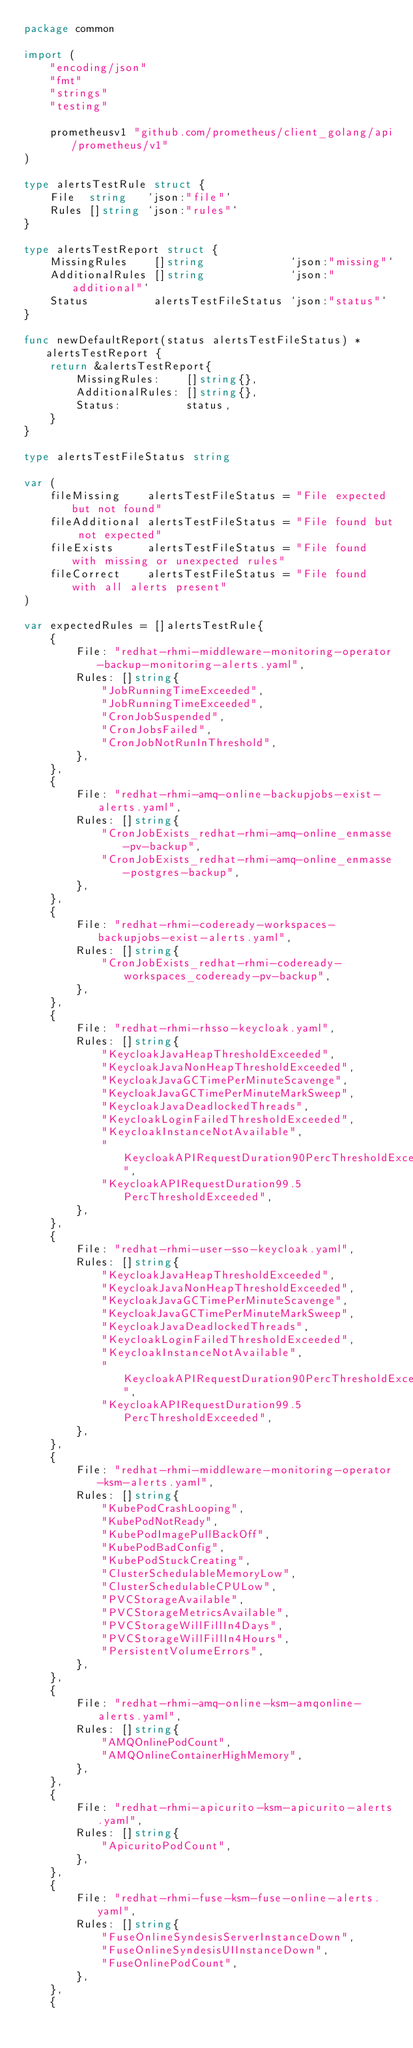<code> <loc_0><loc_0><loc_500><loc_500><_Go_>package common

import (
	"encoding/json"
	"fmt"
	"strings"
	"testing"

	prometheusv1 "github.com/prometheus/client_golang/api/prometheus/v1"
)

type alertsTestRule struct {
	File  string   `json:"file"`
	Rules []string `json:"rules"`
}

type alertsTestReport struct {
	MissingRules    []string             `json:"missing"`
	AdditionalRules []string             `json:"additional"`
	Status          alertsTestFileStatus `json:"status"`
}

func newDefaultReport(status alertsTestFileStatus) *alertsTestReport {
	return &alertsTestReport{
		MissingRules:    []string{},
		AdditionalRules: []string{},
		Status:          status,
	}
}

type alertsTestFileStatus string

var (
	fileMissing    alertsTestFileStatus = "File expected but not found"
	fileAdditional alertsTestFileStatus = "File found but not expected"
	fileExists     alertsTestFileStatus = "File found with missing or unexpected rules"
	fileCorrect    alertsTestFileStatus = "File found with all alerts present"
)

var expectedRules = []alertsTestRule{
	{
		File: "redhat-rhmi-middleware-monitoring-operator-backup-monitoring-alerts.yaml",
		Rules: []string{
			"JobRunningTimeExceeded",
			"JobRunningTimeExceeded",
			"CronJobSuspended",
			"CronJobsFailed",
			"CronJobNotRunInThreshold",
		},
	},
	{
		File: "redhat-rhmi-amq-online-backupjobs-exist-alerts.yaml",
		Rules: []string{
			"CronJobExists_redhat-rhmi-amq-online_enmasse-pv-backup",
			"CronJobExists_redhat-rhmi-amq-online_enmasse-postgres-backup",
		},
	},
	{
		File: "redhat-rhmi-codeready-workspaces-backupjobs-exist-alerts.yaml",
		Rules: []string{
			"CronJobExists_redhat-rhmi-codeready-workspaces_codeready-pv-backup",
		},
	},
	{
		File: "redhat-rhmi-rhsso-keycloak.yaml",
		Rules: []string{
			"KeycloakJavaHeapThresholdExceeded",
			"KeycloakJavaNonHeapThresholdExceeded",
			"KeycloakJavaGCTimePerMinuteScavenge",
			"KeycloakJavaGCTimePerMinuteMarkSweep",
			"KeycloakJavaDeadlockedThreads",
			"KeycloakLoginFailedThresholdExceeded",
			"KeycloakInstanceNotAvailable",
			"KeycloakAPIRequestDuration90PercThresholdExceeded",
			"KeycloakAPIRequestDuration99.5PercThresholdExceeded",
		},
	},
	{
		File: "redhat-rhmi-user-sso-keycloak.yaml",
		Rules: []string{
			"KeycloakJavaHeapThresholdExceeded",
			"KeycloakJavaNonHeapThresholdExceeded",
			"KeycloakJavaGCTimePerMinuteScavenge",
			"KeycloakJavaGCTimePerMinuteMarkSweep",
			"KeycloakJavaDeadlockedThreads",
			"KeycloakLoginFailedThresholdExceeded",
			"KeycloakInstanceNotAvailable",
			"KeycloakAPIRequestDuration90PercThresholdExceeded",
			"KeycloakAPIRequestDuration99.5PercThresholdExceeded",
		},
	},
	{
		File: "redhat-rhmi-middleware-monitoring-operator-ksm-alerts.yaml",
		Rules: []string{
			"KubePodCrashLooping",
			"KubePodNotReady",
			"KubePodImagePullBackOff",
			"KubePodBadConfig",
			"KubePodStuckCreating",
			"ClusterSchedulableMemoryLow",
			"ClusterSchedulableCPULow",
			"PVCStorageAvailable",
			"PVCStorageMetricsAvailable",
			"PVCStorageWillFillIn4Days",
			"PVCStorageWillFillIn4Hours",
			"PersistentVolumeErrors",
		},
	},
	{
		File: "redhat-rhmi-amq-online-ksm-amqonline-alerts.yaml",
		Rules: []string{
			"AMQOnlinePodCount",
			"AMQOnlineContainerHighMemory",
		},
	},
	{
		File: "redhat-rhmi-apicurito-ksm-apicurito-alerts.yaml",
		Rules: []string{
			"ApicuritoPodCount",
		},
	},
	{
		File: "redhat-rhmi-fuse-ksm-fuse-online-alerts.yaml",
		Rules: []string{
			"FuseOnlineSyndesisServerInstanceDown",
			"FuseOnlineSyndesisUIInstanceDown",
			"FuseOnlinePodCount",
		},
	},
	{</code> 